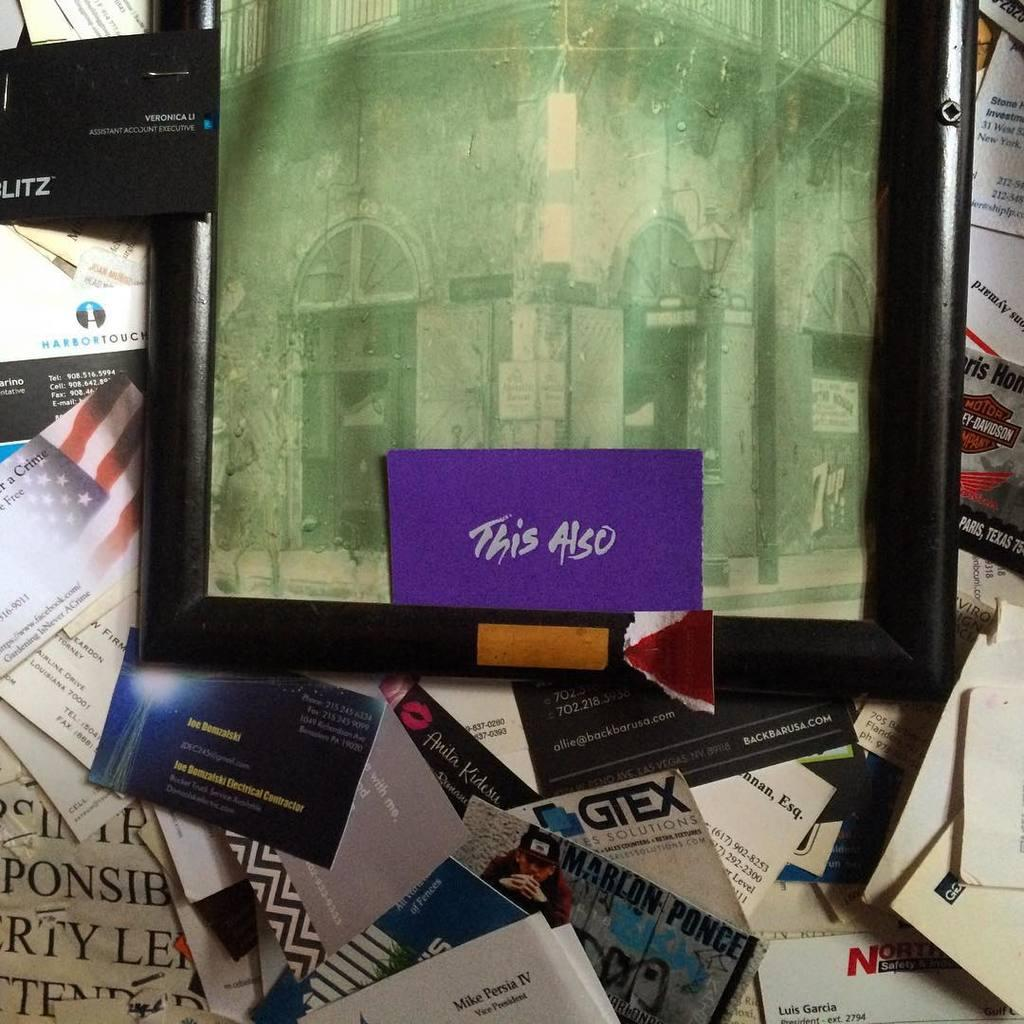<image>
Write a terse but informative summary of the picture. A purple card with the words This Also sits inside a black frame with a picture in it. 